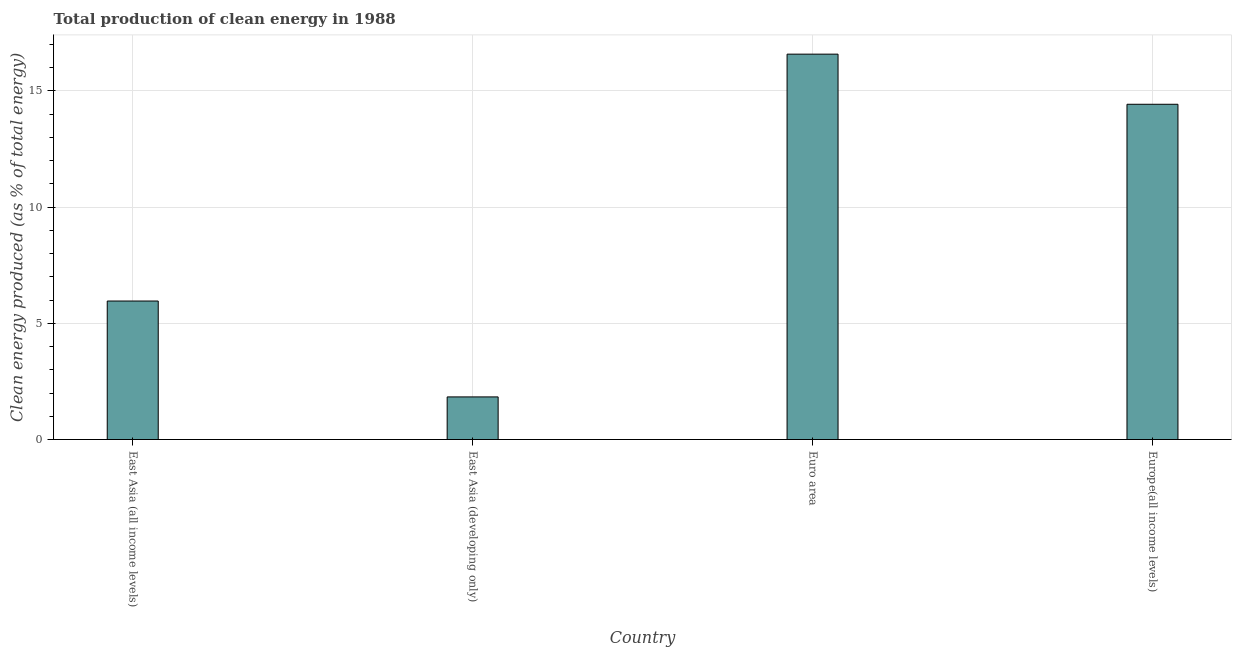What is the title of the graph?
Give a very brief answer. Total production of clean energy in 1988. What is the label or title of the X-axis?
Offer a very short reply. Country. What is the label or title of the Y-axis?
Your answer should be compact. Clean energy produced (as % of total energy). What is the production of clean energy in East Asia (all income levels)?
Offer a very short reply. 5.96. Across all countries, what is the maximum production of clean energy?
Keep it short and to the point. 16.58. Across all countries, what is the minimum production of clean energy?
Provide a succinct answer. 1.83. In which country was the production of clean energy minimum?
Keep it short and to the point. East Asia (developing only). What is the sum of the production of clean energy?
Make the answer very short. 38.79. What is the difference between the production of clean energy in East Asia (developing only) and Euro area?
Ensure brevity in your answer.  -14.75. What is the average production of clean energy per country?
Offer a terse response. 9.7. What is the median production of clean energy?
Offer a very short reply. 10.19. In how many countries, is the production of clean energy greater than 4 %?
Ensure brevity in your answer.  3. What is the ratio of the production of clean energy in Euro area to that in Europe(all income levels)?
Keep it short and to the point. 1.15. Is the production of clean energy in East Asia (all income levels) less than that in Europe(all income levels)?
Ensure brevity in your answer.  Yes. What is the difference between the highest and the second highest production of clean energy?
Provide a short and direct response. 2.16. Is the sum of the production of clean energy in East Asia (developing only) and Euro area greater than the maximum production of clean energy across all countries?
Make the answer very short. Yes. What is the difference between the highest and the lowest production of clean energy?
Give a very brief answer. 14.75. In how many countries, is the production of clean energy greater than the average production of clean energy taken over all countries?
Give a very brief answer. 2. How many bars are there?
Your answer should be very brief. 4. How many countries are there in the graph?
Offer a terse response. 4. What is the difference between two consecutive major ticks on the Y-axis?
Give a very brief answer. 5. What is the Clean energy produced (as % of total energy) of East Asia (all income levels)?
Give a very brief answer. 5.96. What is the Clean energy produced (as % of total energy) in East Asia (developing only)?
Keep it short and to the point. 1.83. What is the Clean energy produced (as % of total energy) in Euro area?
Offer a very short reply. 16.58. What is the Clean energy produced (as % of total energy) in Europe(all income levels)?
Provide a short and direct response. 14.42. What is the difference between the Clean energy produced (as % of total energy) in East Asia (all income levels) and East Asia (developing only)?
Offer a very short reply. 4.13. What is the difference between the Clean energy produced (as % of total energy) in East Asia (all income levels) and Euro area?
Keep it short and to the point. -10.62. What is the difference between the Clean energy produced (as % of total energy) in East Asia (all income levels) and Europe(all income levels)?
Offer a very short reply. -8.46. What is the difference between the Clean energy produced (as % of total energy) in East Asia (developing only) and Euro area?
Give a very brief answer. -14.75. What is the difference between the Clean energy produced (as % of total energy) in East Asia (developing only) and Europe(all income levels)?
Provide a succinct answer. -12.59. What is the difference between the Clean energy produced (as % of total energy) in Euro area and Europe(all income levels)?
Keep it short and to the point. 2.16. What is the ratio of the Clean energy produced (as % of total energy) in East Asia (all income levels) to that in Euro area?
Give a very brief answer. 0.36. What is the ratio of the Clean energy produced (as % of total energy) in East Asia (all income levels) to that in Europe(all income levels)?
Offer a very short reply. 0.41. What is the ratio of the Clean energy produced (as % of total energy) in East Asia (developing only) to that in Euro area?
Give a very brief answer. 0.11. What is the ratio of the Clean energy produced (as % of total energy) in East Asia (developing only) to that in Europe(all income levels)?
Your answer should be compact. 0.13. What is the ratio of the Clean energy produced (as % of total energy) in Euro area to that in Europe(all income levels)?
Give a very brief answer. 1.15. 